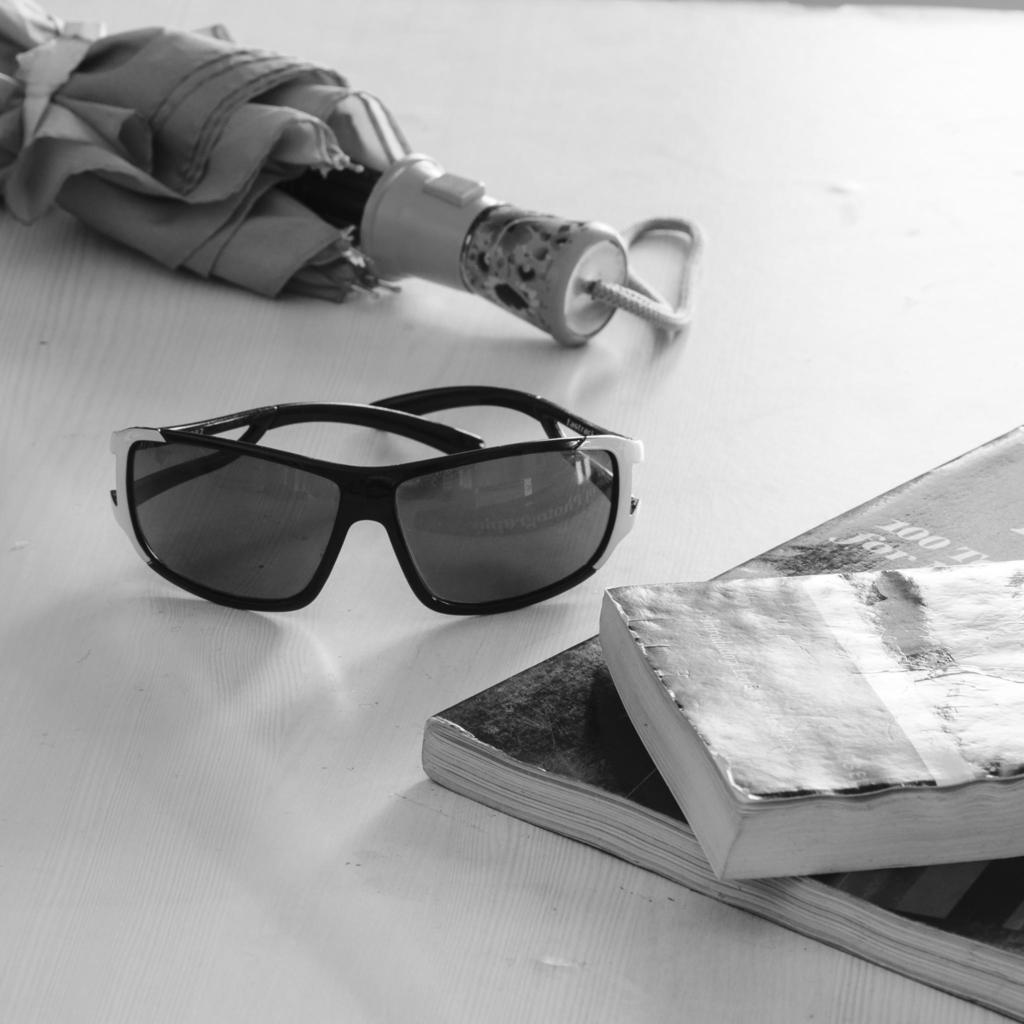What piece of furniture is present in the image? There is a table in the image. What items can be seen on the table? There are books, spectacles, and an umbrella on the table. How much profit can be made from the sack in the image? There is no sack present in the image, so it is not possible to determine any profit. 